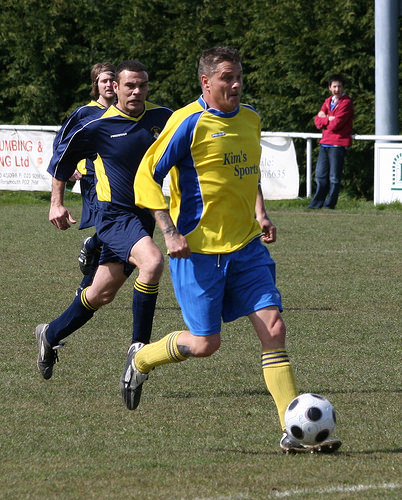<image>
Can you confirm if the soccer ball is behind the man? No. The soccer ball is not behind the man. From this viewpoint, the soccer ball appears to be positioned elsewhere in the scene. 